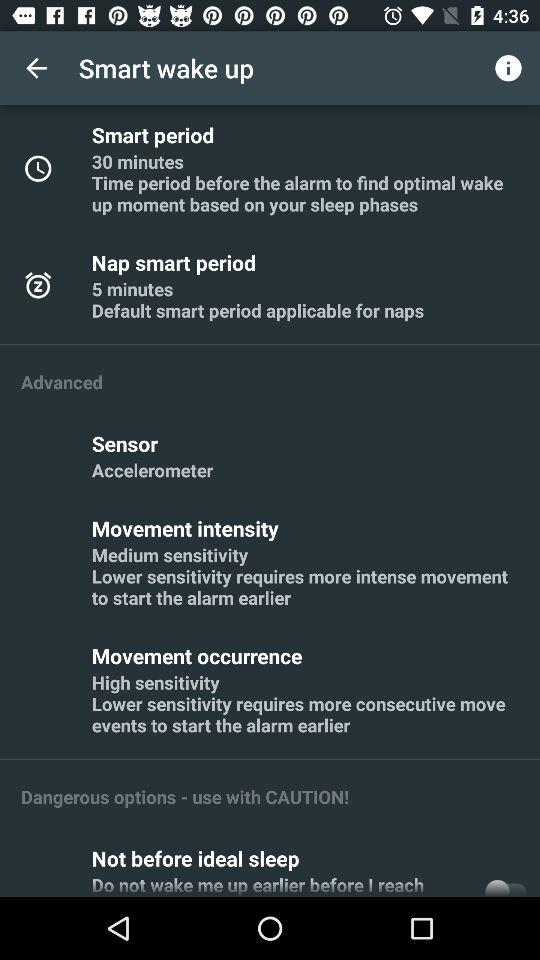What is the setting of "Sensor"? The setting is "Accelerometer". 